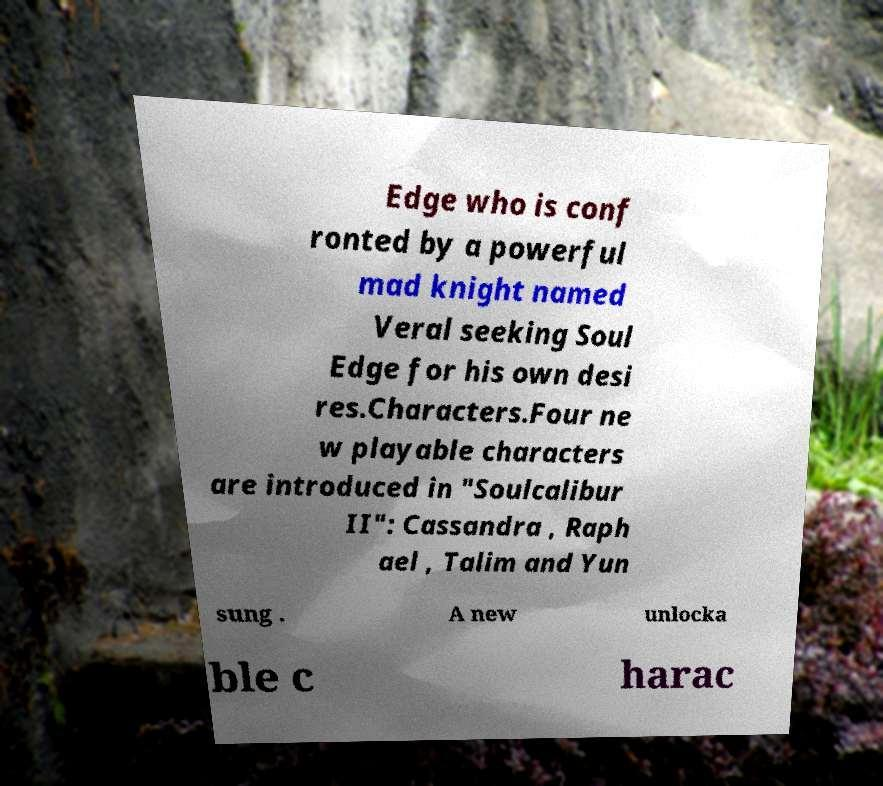Can you accurately transcribe the text from the provided image for me? Edge who is conf ronted by a powerful mad knight named Veral seeking Soul Edge for his own desi res.Characters.Four ne w playable characters are introduced in "Soulcalibur II": Cassandra , Raph ael , Talim and Yun sung . A new unlocka ble c harac 